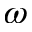<formula> <loc_0><loc_0><loc_500><loc_500>\omega</formula> 